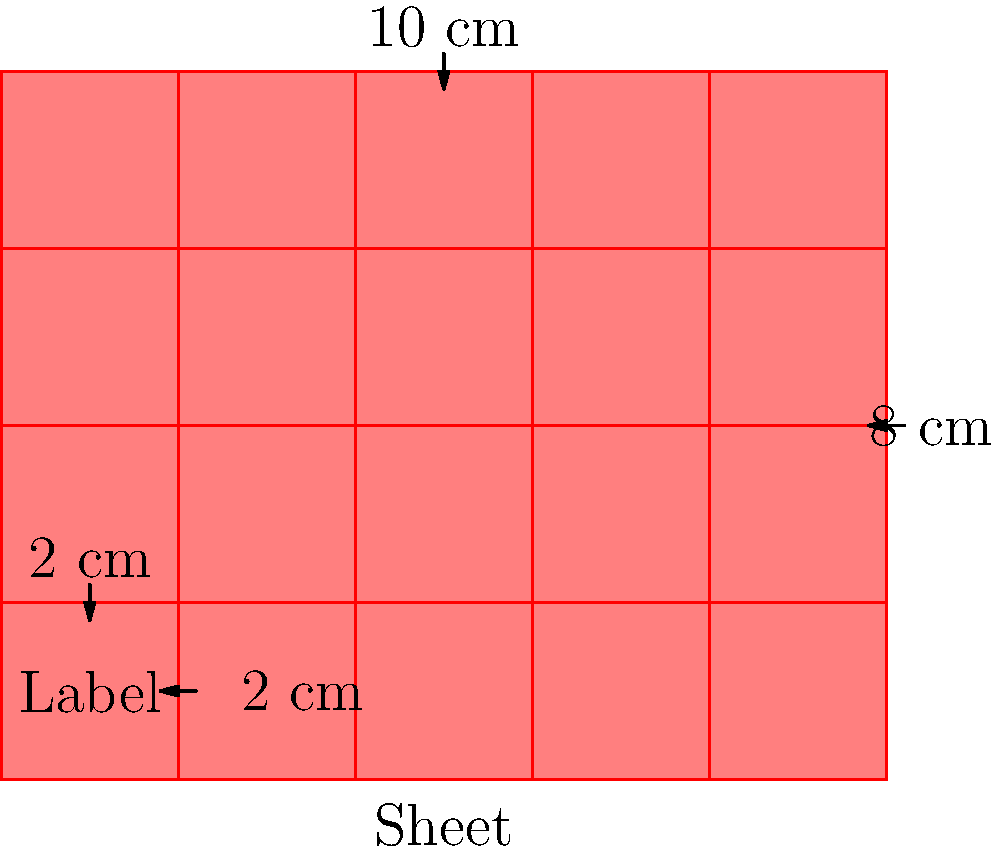As a cosmetics CEO focused on traditional packaging, you're evaluating the efficiency of label placement on packaging sheets. Your rectangular labels measure 2 cm × 2 cm, and the sheet is 10 cm × 8 cm. What is the maximum number of complete groups of labels that can be arranged on the sheet without overlapping or extending beyond the sheet's edges? Define a group as a set of labels that can be rotated or reflected to produce all other groups on the sheet. To solve this problem, we need to follow these steps:

1) First, let's determine how many labels fit on the sheet:
   - Sheet dimensions: 10 cm × 8 cm
   - Label dimensions: 2 cm × 2 cm
   - Labels per row: 10 cm ÷ 2 cm = 5
   - Labels per column: 8 cm ÷ 2 cm = 4
   - Total labels: 5 × 4 = 20

2) Now, we need to identify the groups. A group is a set of labels that can produce all other arrangements through rotation or reflection. In this case, the smallest such group is a 2×2 square of labels.

3) Let's count how many 2×2 groups we can fit:
   - Horizontally: We can fit 2 complete 2×2 groups (4 labels wide)
   - Vertically: We can fit 1 complete 2×2 group (4 labels tall)

4) Therefore, the total number of complete 2×2 groups is:
   2 × 1 = 2 groups

This arrangement utilizes 16 out of the 20 possible label positions, leaving 4 individual labels that cannot form a complete group.
Answer: 2 groups 